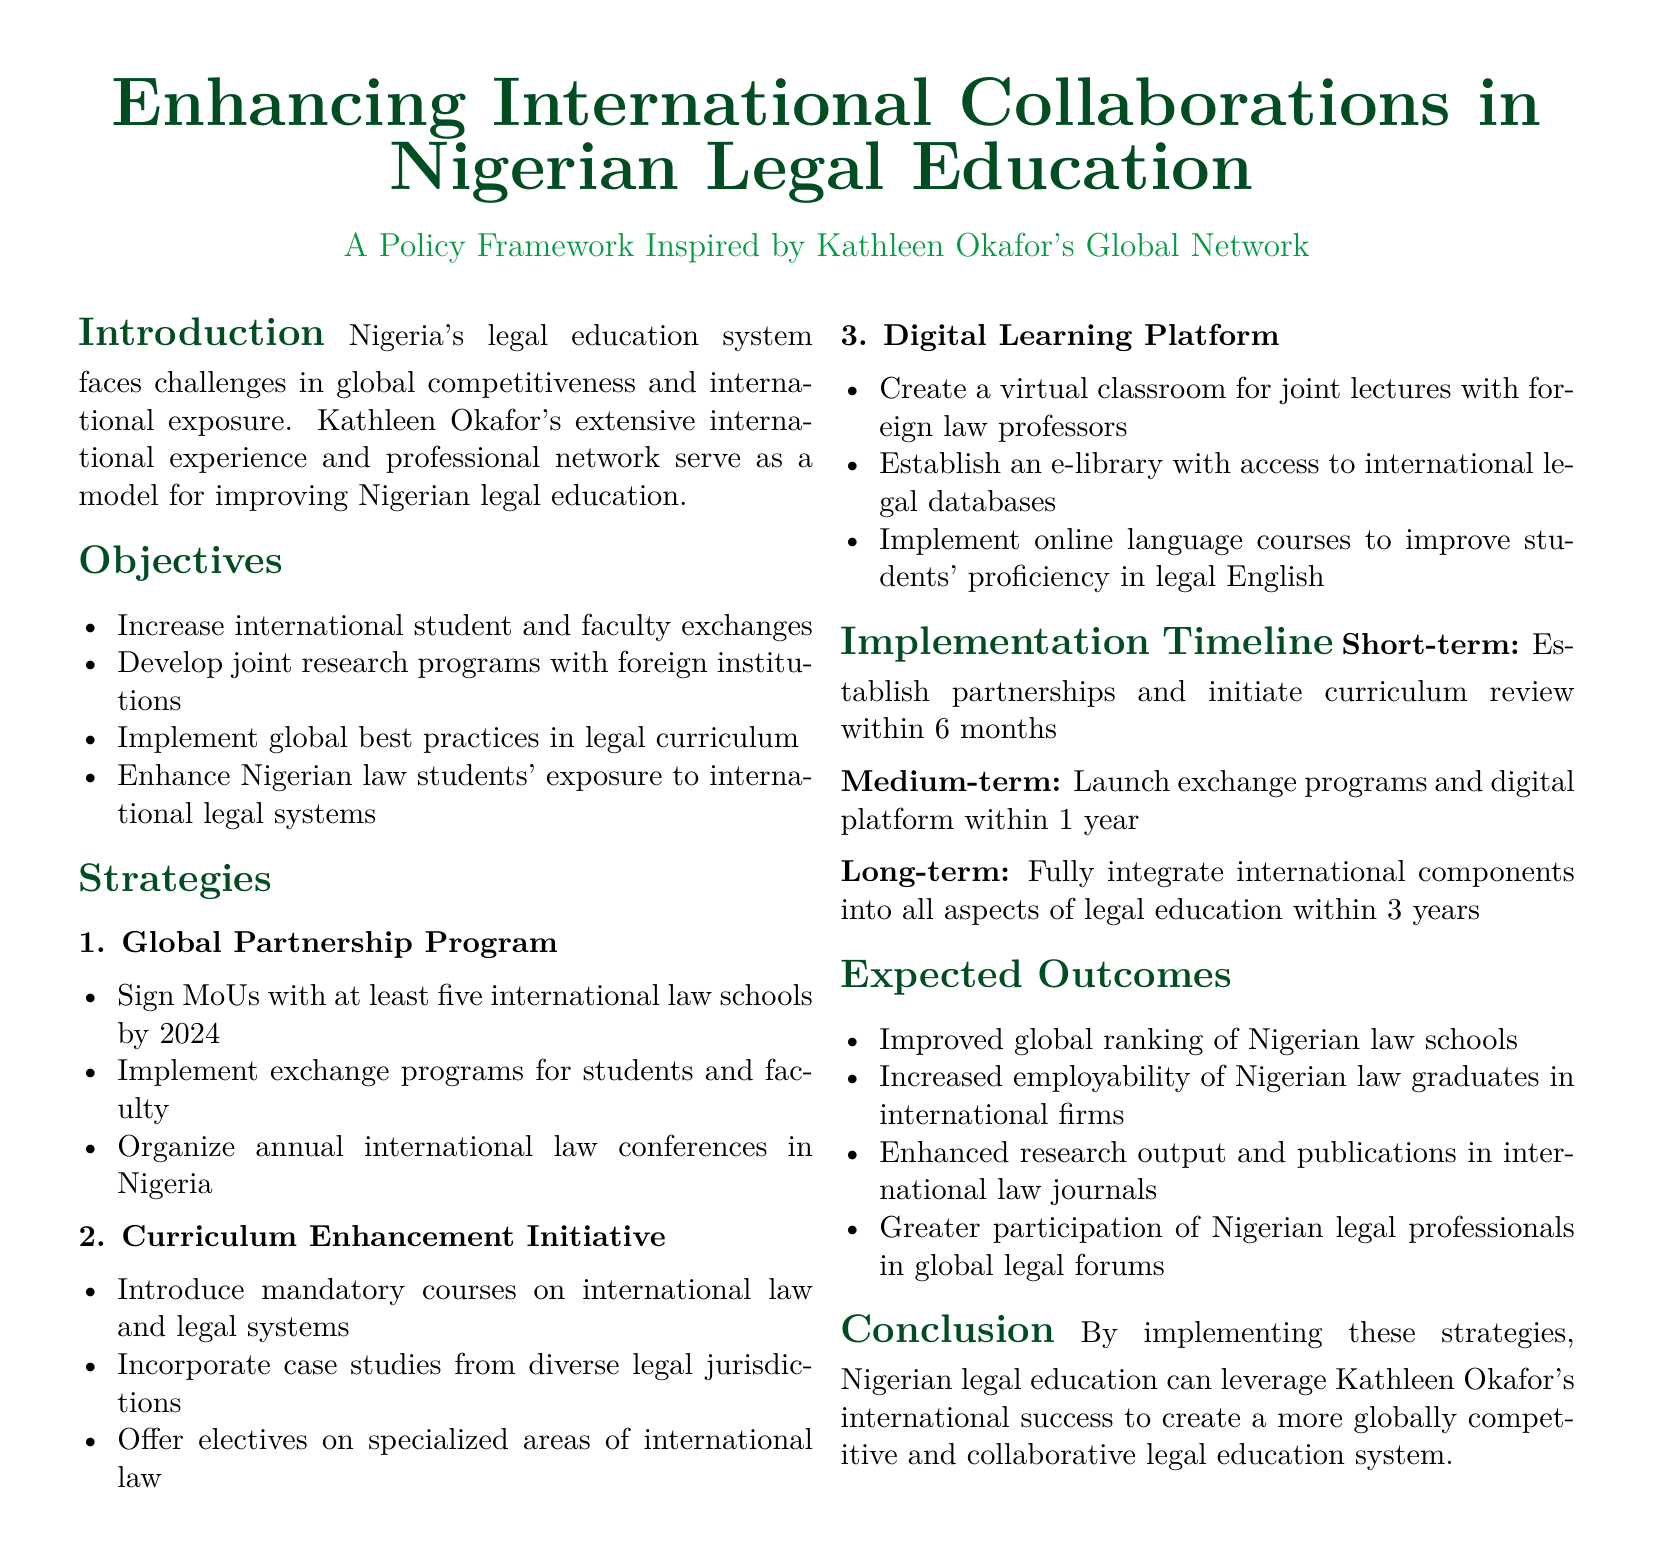What is the title of the document? The title of the document is prominently displayed at the beginning, summarizing its focus on collaborations in legal education.
Answer: Enhancing International Collaborations in Nigerian Legal Education Who is the inspiration for the policy framework? The document highlights a specific professional figure whose global network serves as a model.
Answer: Kathleen Okafor How many international law schools does the document aim to partner with by 2024? This is mentioned as a specific goal in the Global Partnership Program strategy section.
Answer: Five What is one of the objectives of the policy document? The objectives section lists multiple aims related to international collaboration in legal education.
Answer: Increase international student and faculty exchanges What is the implementation timeline for establishing partnerships? This is mentioned in the Implementation Timeline section, detailing a short-term goal related to partnerships.
Answer: 6 months What is one expected outcome of the proposed strategies? The Expected Outcomes section lists multiple anticipated benefits resulting from successful implementation.
Answer: Improved global ranking of Nigerian law schools What type of course is mandatory according to the Curriculum Enhancement Initiative? The strategies mention specific types of courses that will be required for students.
Answer: International law What digital initiative is proposed for joint lectures? This information is found in the Digital Learning Platform strategy section, outlining technological enhancements.
Answer: Virtual classroom What is the long-term goal for integrating international components into legal education? The Implementation Timeline provides a timeframe for achieving this integration.
Answer: 3 years 